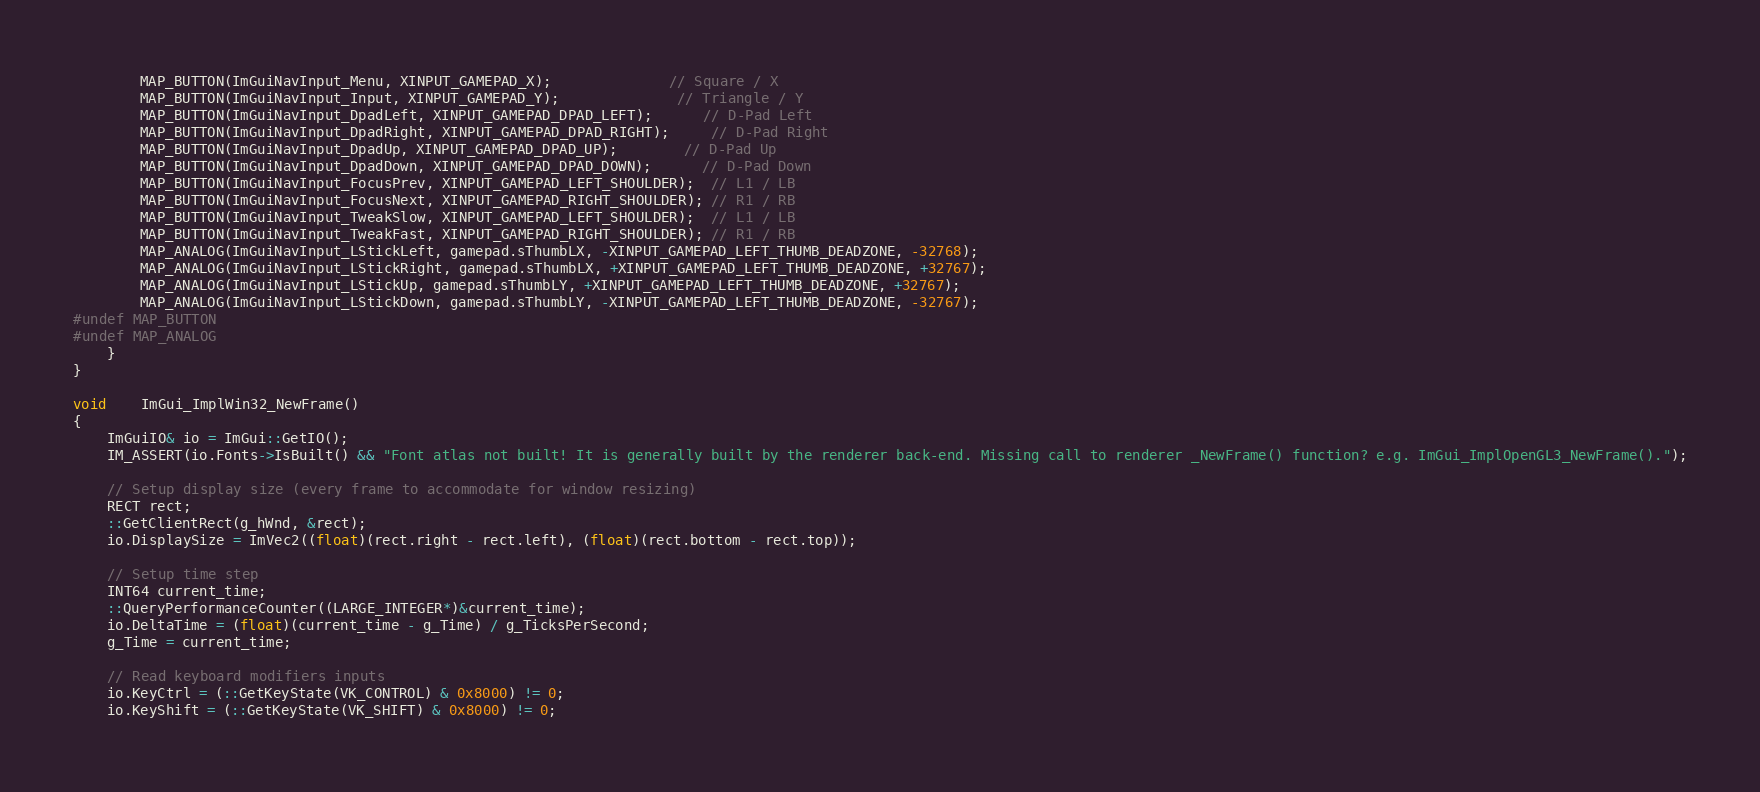<code> <loc_0><loc_0><loc_500><loc_500><_C++_>        MAP_BUTTON(ImGuiNavInput_Menu, XINPUT_GAMEPAD_X);              // Square / X
        MAP_BUTTON(ImGuiNavInput_Input, XINPUT_GAMEPAD_Y);              // Triangle / Y
        MAP_BUTTON(ImGuiNavInput_DpadLeft, XINPUT_GAMEPAD_DPAD_LEFT);      // D-Pad Left
        MAP_BUTTON(ImGuiNavInput_DpadRight, XINPUT_GAMEPAD_DPAD_RIGHT);     // D-Pad Right
        MAP_BUTTON(ImGuiNavInput_DpadUp, XINPUT_GAMEPAD_DPAD_UP);        // D-Pad Up
        MAP_BUTTON(ImGuiNavInput_DpadDown, XINPUT_GAMEPAD_DPAD_DOWN);      // D-Pad Down
        MAP_BUTTON(ImGuiNavInput_FocusPrev, XINPUT_GAMEPAD_LEFT_SHOULDER);  // L1 / LB
        MAP_BUTTON(ImGuiNavInput_FocusNext, XINPUT_GAMEPAD_RIGHT_SHOULDER); // R1 / RB
        MAP_BUTTON(ImGuiNavInput_TweakSlow, XINPUT_GAMEPAD_LEFT_SHOULDER);  // L1 / LB
        MAP_BUTTON(ImGuiNavInput_TweakFast, XINPUT_GAMEPAD_RIGHT_SHOULDER); // R1 / RB
        MAP_ANALOG(ImGuiNavInput_LStickLeft, gamepad.sThumbLX, -XINPUT_GAMEPAD_LEFT_THUMB_DEADZONE, -32768);
        MAP_ANALOG(ImGuiNavInput_LStickRight, gamepad.sThumbLX, +XINPUT_GAMEPAD_LEFT_THUMB_DEADZONE, +32767);
        MAP_ANALOG(ImGuiNavInput_LStickUp, gamepad.sThumbLY, +XINPUT_GAMEPAD_LEFT_THUMB_DEADZONE, +32767);
        MAP_ANALOG(ImGuiNavInput_LStickDown, gamepad.sThumbLY, -XINPUT_GAMEPAD_LEFT_THUMB_DEADZONE, -32767);
#undef MAP_BUTTON
#undef MAP_ANALOG
    }
}

void    ImGui_ImplWin32_NewFrame()
{
    ImGuiIO& io = ImGui::GetIO();
    IM_ASSERT(io.Fonts->IsBuilt() && "Font atlas not built! It is generally built by the renderer back-end. Missing call to renderer _NewFrame() function? e.g. ImGui_ImplOpenGL3_NewFrame().");

    // Setup display size (every frame to accommodate for window resizing)
    RECT rect;
    ::GetClientRect(g_hWnd, &rect);
    io.DisplaySize = ImVec2((float)(rect.right - rect.left), (float)(rect.bottom - rect.top));

    // Setup time step
    INT64 current_time;
    ::QueryPerformanceCounter((LARGE_INTEGER*)&current_time);
    io.DeltaTime = (float)(current_time - g_Time) / g_TicksPerSecond;
    g_Time = current_time;

    // Read keyboard modifiers inputs
    io.KeyCtrl = (::GetKeyState(VK_CONTROL) & 0x8000) != 0;
    io.KeyShift = (::GetKeyState(VK_SHIFT) & 0x8000) != 0;</code> 